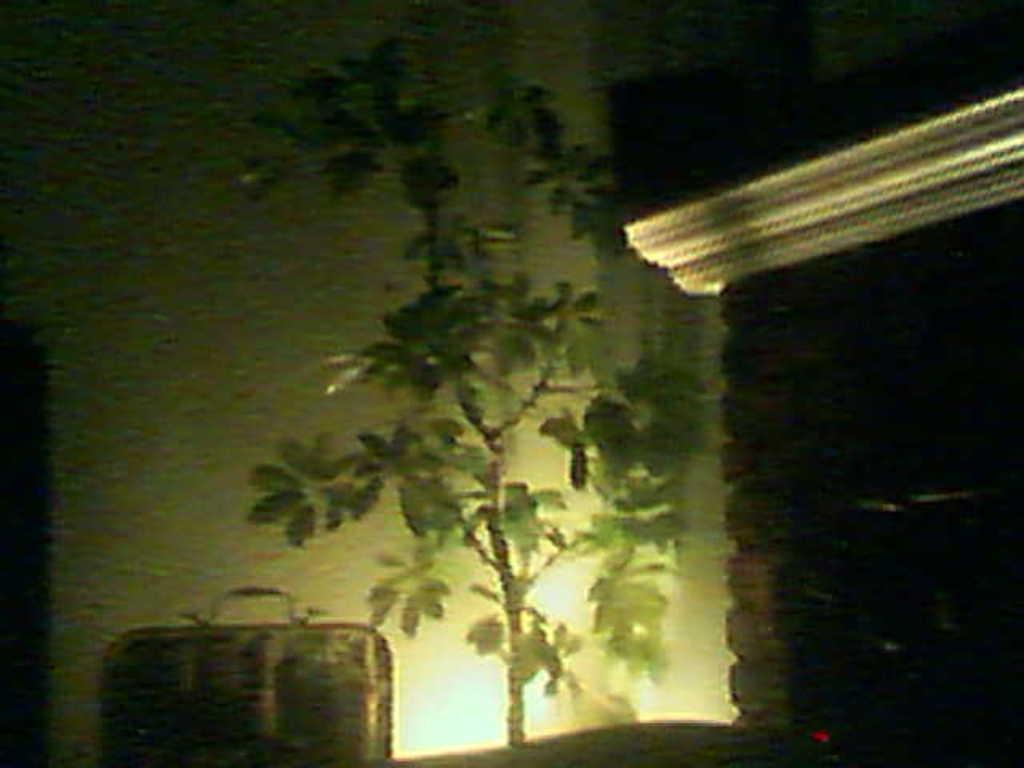Describe this image in one or two sentences. In the middle of the image we can see a plant and suitcase. Behind them there is wall. 